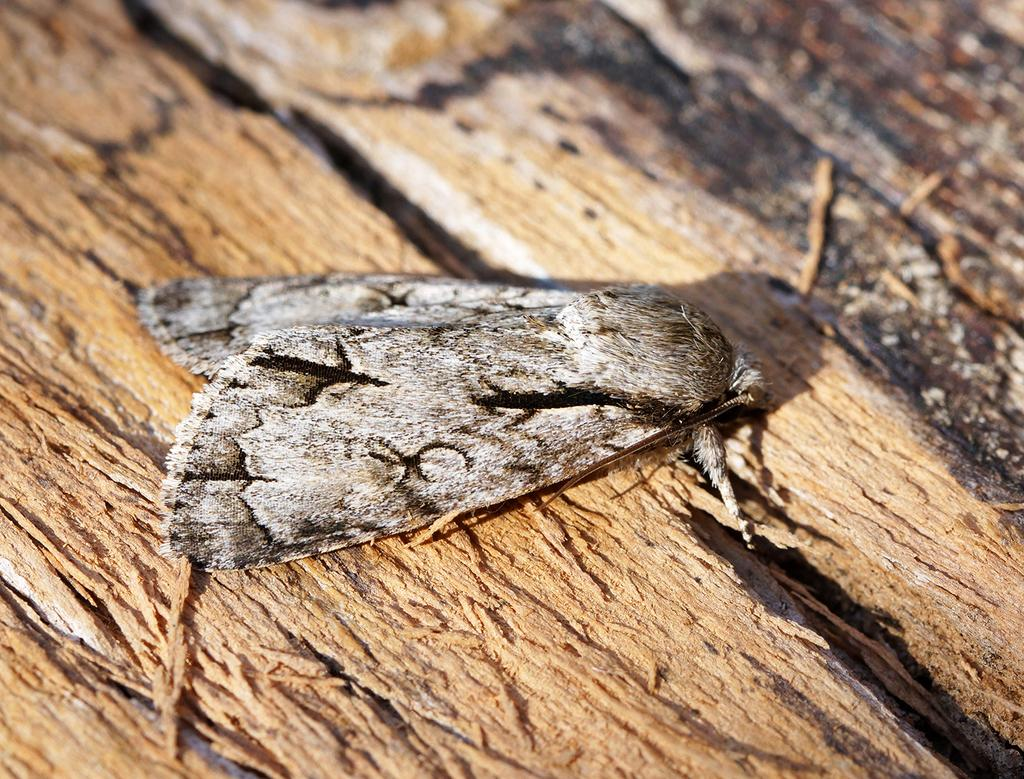What is present on the wooden surface in the image? There is an insect on the wooden surface in the image. What type of zephyr can be seen in the image? There is no zephyr present in the image; it is an insect on a wooden surface. What type of print is visible on the wooden surface? There is no print visible on the wooden surface; it only shows an insect. 